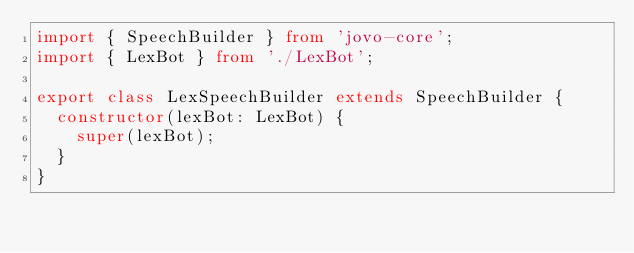Convert code to text. <code><loc_0><loc_0><loc_500><loc_500><_TypeScript_>import { SpeechBuilder } from 'jovo-core';
import { LexBot } from './LexBot';

export class LexSpeechBuilder extends SpeechBuilder {
  constructor(lexBot: LexBot) {
    super(lexBot);
  }
}
</code> 